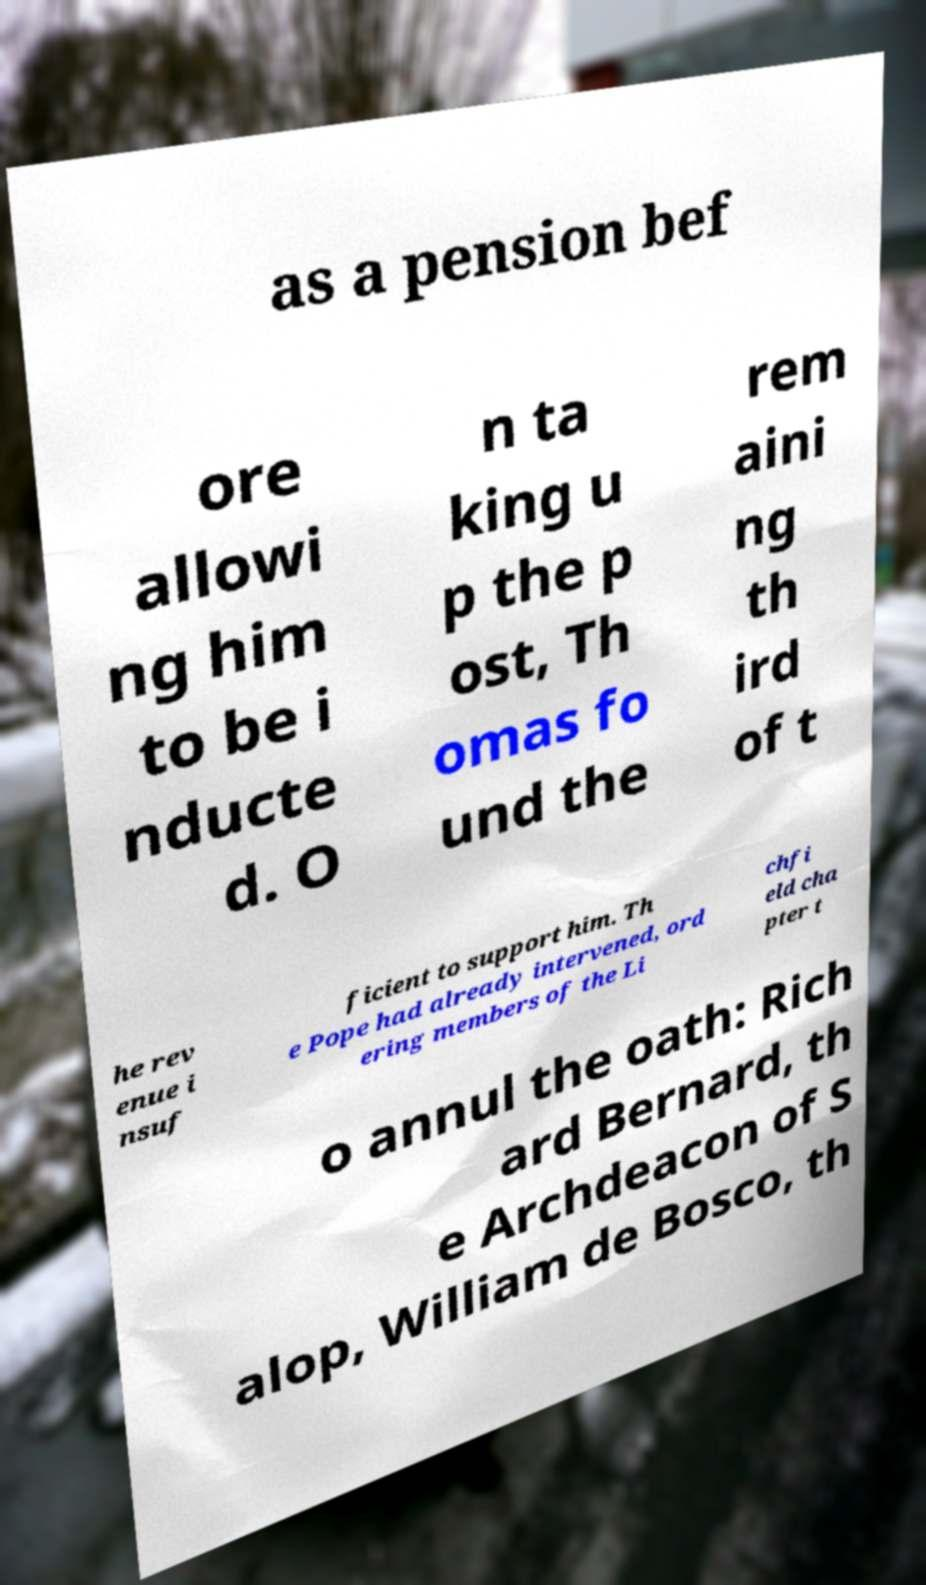Please read and relay the text visible in this image. What does it say? as a pension bef ore allowi ng him to be i nducte d. O n ta king u p the p ost, Th omas fo und the rem aini ng th ird of t he rev enue i nsuf ficient to support him. Th e Pope had already intervened, ord ering members of the Li chfi eld cha pter t o annul the oath: Rich ard Bernard, th e Archdeacon of S alop, William de Bosco, th 